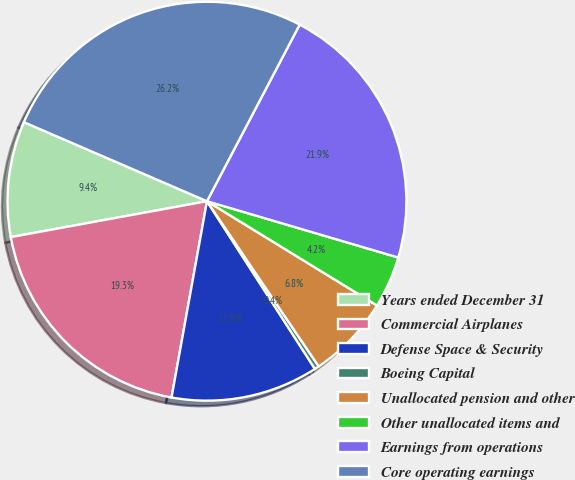Convert chart. <chart><loc_0><loc_0><loc_500><loc_500><pie_chart><fcel>Years ended December 31<fcel>Commercial Airplanes<fcel>Defense Space & Security<fcel>Boeing Capital<fcel>Unallocated pension and other<fcel>Other unallocated items and<fcel>Earnings from operations<fcel>Core operating earnings<nl><fcel>9.37%<fcel>19.28%<fcel>11.95%<fcel>0.36%<fcel>6.78%<fcel>4.2%<fcel>21.87%<fcel>26.21%<nl></chart> 